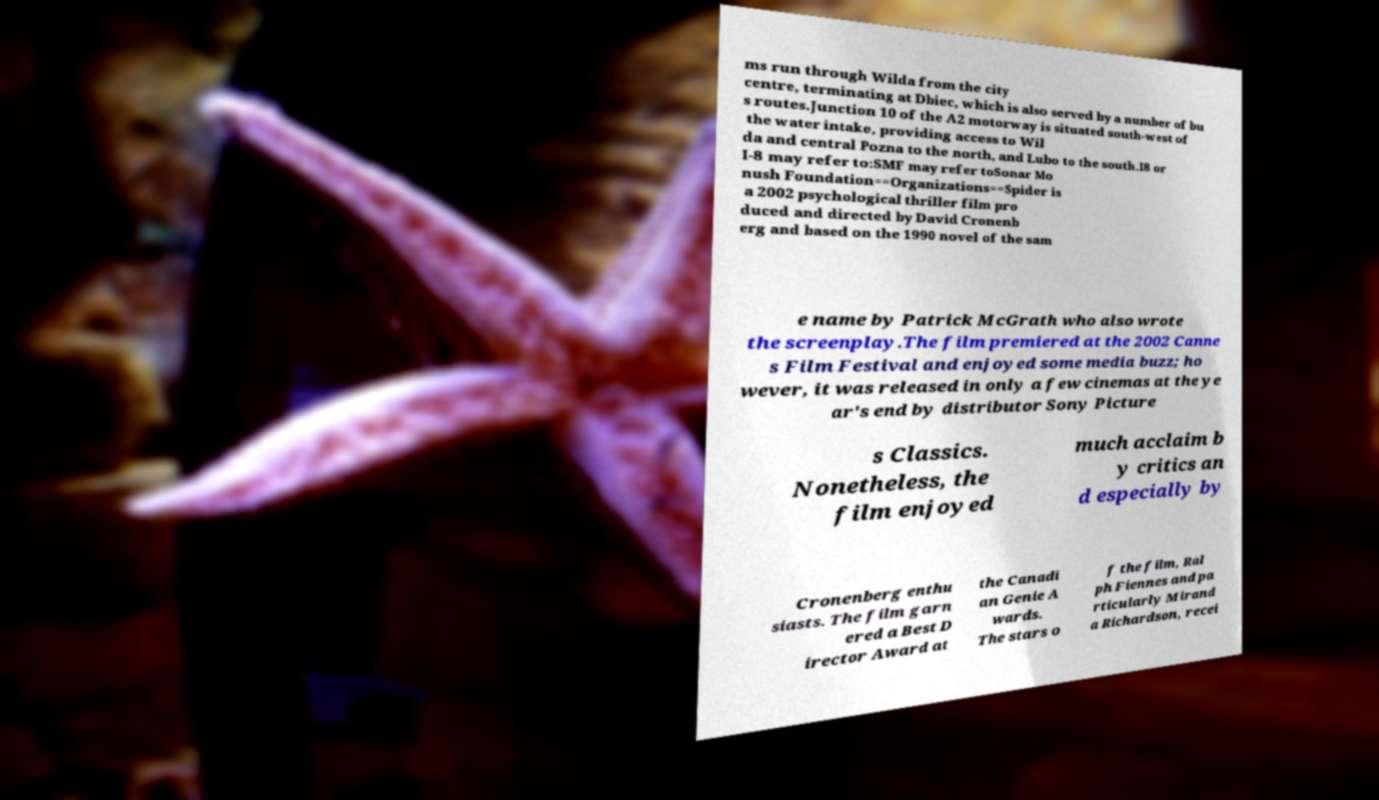Please identify and transcribe the text found in this image. ms run through Wilda from the city centre, terminating at Dbiec, which is also served by a number of bu s routes.Junction 10 of the A2 motorway is situated south-west of the water intake, providing access to Wil da and central Pozna to the north, and Lubo to the south.I8 or I-8 may refer to:SMF may refer toSonar Mo nush Foundation==Organizations==Spider is a 2002 psychological thriller film pro duced and directed by David Cronenb erg and based on the 1990 novel of the sam e name by Patrick McGrath who also wrote the screenplay.The film premiered at the 2002 Canne s Film Festival and enjoyed some media buzz; ho wever, it was released in only a few cinemas at the ye ar's end by distributor Sony Picture s Classics. Nonetheless, the film enjoyed much acclaim b y critics an d especially by Cronenberg enthu siasts. The film garn ered a Best D irector Award at the Canadi an Genie A wards. The stars o f the film, Ral ph Fiennes and pa rticularly Mirand a Richardson, recei 